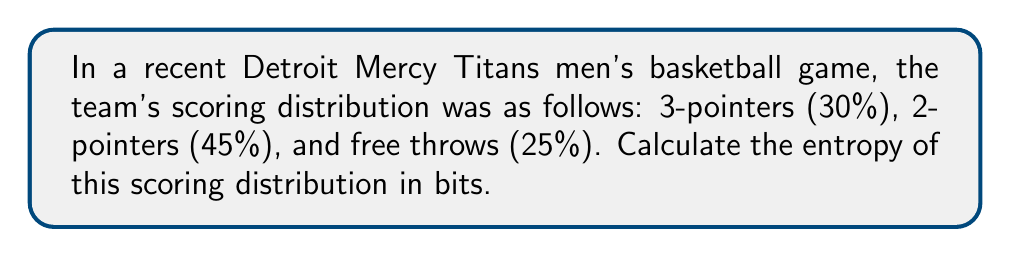Can you answer this question? To calculate the entropy of the scoring distribution, we'll use the formula for Shannon entropy:

$$H = -\sum_{i=1}^{n} p_i \log_2(p_i)$$

Where:
- $H$ is the entropy in bits
- $p_i$ is the probability of each outcome
- $n$ is the number of possible outcomes

Let's break it down step-by-step:

1) We have three outcomes with their probabilities:
   - 3-pointers: $p_1 = 0.30$
   - 2-pointers: $p_2 = 0.45$
   - Free throws: $p_3 = 0.25$

2) Now, let's calculate each term of the sum:

   For 3-pointers:
   $-p_1 \log_2(p_1) = -0.30 \log_2(0.30) = 0.521$

   For 2-pointers:
   $-p_2 \log_2(p_2) = -0.45 \log_2(0.45) = 0.517$

   For free throws:
   $-p_3 \log_2(p_3) = -0.25 \log_2(0.25) = 0.500$

3) Sum up all these terms:

   $H = 0.521 + 0.517 + 0.500 = 1.538$

Therefore, the entropy of the scoring distribution is approximately 1.538 bits.
Answer: $1.538$ bits 